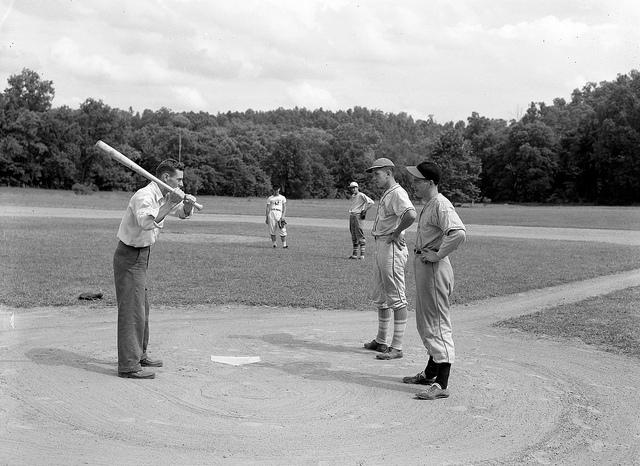Is this a modern photo?
Write a very short answer. No. Are all these people baseball players?
Answer briefly. Yes. Is the batter in uniform?
Keep it brief. No. 